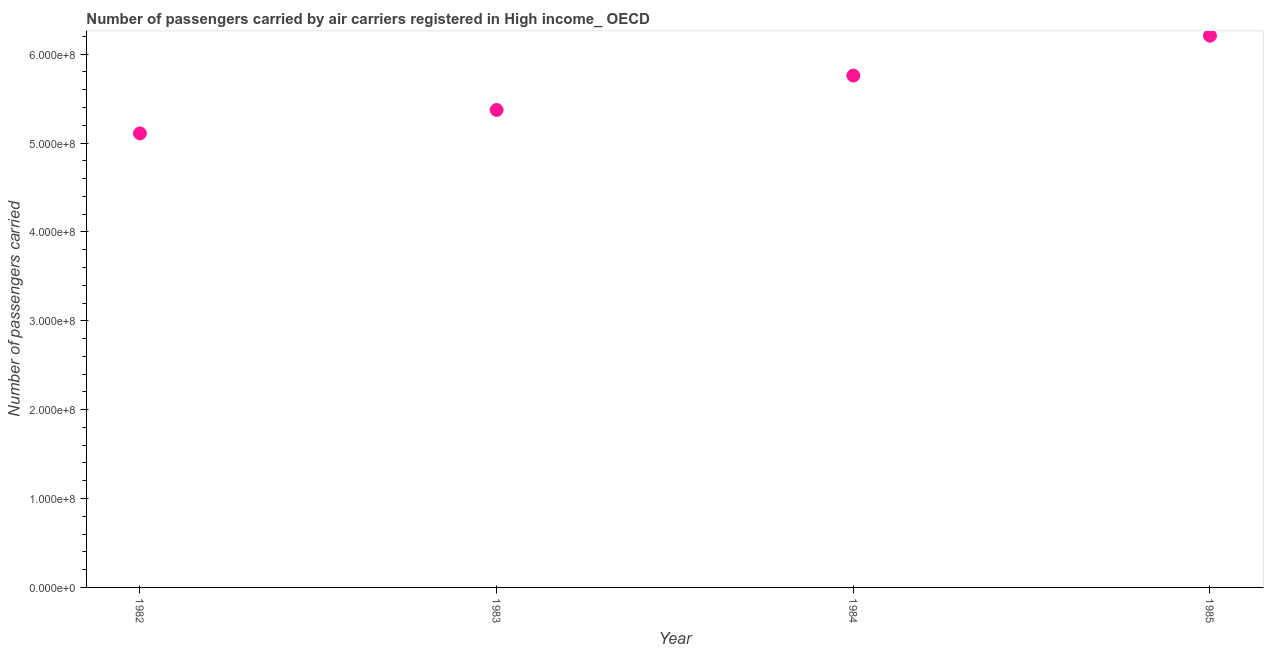What is the number of passengers carried in 1984?
Make the answer very short. 5.76e+08. Across all years, what is the maximum number of passengers carried?
Offer a terse response. 6.21e+08. Across all years, what is the minimum number of passengers carried?
Keep it short and to the point. 5.11e+08. In which year was the number of passengers carried maximum?
Give a very brief answer. 1985. What is the sum of the number of passengers carried?
Give a very brief answer. 2.24e+09. What is the difference between the number of passengers carried in 1982 and 1984?
Make the answer very short. -6.50e+07. What is the average number of passengers carried per year?
Your answer should be compact. 5.61e+08. What is the median number of passengers carried?
Provide a succinct answer. 5.57e+08. What is the ratio of the number of passengers carried in 1983 to that in 1985?
Your answer should be very brief. 0.87. Is the difference between the number of passengers carried in 1983 and 1984 greater than the difference between any two years?
Give a very brief answer. No. What is the difference between the highest and the second highest number of passengers carried?
Your answer should be very brief. 4.49e+07. Is the sum of the number of passengers carried in 1982 and 1983 greater than the maximum number of passengers carried across all years?
Offer a very short reply. Yes. What is the difference between the highest and the lowest number of passengers carried?
Offer a very short reply. 1.10e+08. How many dotlines are there?
Your answer should be very brief. 1. How many years are there in the graph?
Offer a terse response. 4. Are the values on the major ticks of Y-axis written in scientific E-notation?
Offer a very short reply. Yes. Does the graph contain any zero values?
Keep it short and to the point. No. What is the title of the graph?
Provide a short and direct response. Number of passengers carried by air carriers registered in High income_ OECD. What is the label or title of the X-axis?
Ensure brevity in your answer.  Year. What is the label or title of the Y-axis?
Provide a succinct answer. Number of passengers carried. What is the Number of passengers carried in 1982?
Provide a succinct answer. 5.11e+08. What is the Number of passengers carried in 1983?
Your answer should be compact. 5.37e+08. What is the Number of passengers carried in 1984?
Offer a terse response. 5.76e+08. What is the Number of passengers carried in 1985?
Offer a terse response. 6.21e+08. What is the difference between the Number of passengers carried in 1982 and 1983?
Offer a terse response. -2.63e+07. What is the difference between the Number of passengers carried in 1982 and 1984?
Your answer should be compact. -6.50e+07. What is the difference between the Number of passengers carried in 1982 and 1985?
Your answer should be compact. -1.10e+08. What is the difference between the Number of passengers carried in 1983 and 1984?
Provide a short and direct response. -3.87e+07. What is the difference between the Number of passengers carried in 1983 and 1985?
Make the answer very short. -8.36e+07. What is the difference between the Number of passengers carried in 1984 and 1985?
Provide a succinct answer. -4.49e+07. What is the ratio of the Number of passengers carried in 1982 to that in 1983?
Provide a short and direct response. 0.95. What is the ratio of the Number of passengers carried in 1982 to that in 1984?
Provide a succinct answer. 0.89. What is the ratio of the Number of passengers carried in 1982 to that in 1985?
Offer a terse response. 0.82. What is the ratio of the Number of passengers carried in 1983 to that in 1984?
Ensure brevity in your answer.  0.93. What is the ratio of the Number of passengers carried in 1983 to that in 1985?
Give a very brief answer. 0.86. What is the ratio of the Number of passengers carried in 1984 to that in 1985?
Offer a very short reply. 0.93. 